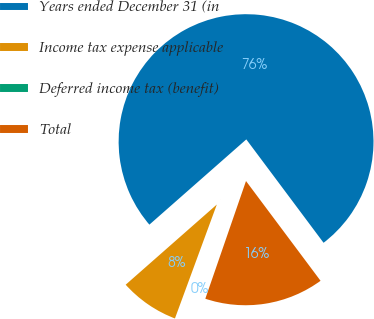Convert chart. <chart><loc_0><loc_0><loc_500><loc_500><pie_chart><fcel>Years ended December 31 (in<fcel>Income tax expense applicable<fcel>Deferred income tax (benefit)<fcel>Total<nl><fcel>76.27%<fcel>7.91%<fcel>0.31%<fcel>15.51%<nl></chart> 